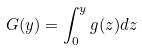Convert formula to latex. <formula><loc_0><loc_0><loc_500><loc_500>G ( y ) = \int _ { 0 } ^ { y } g ( z ) d z</formula> 